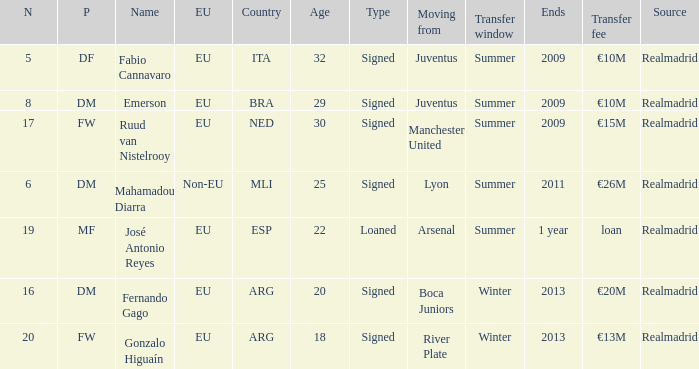How many numbers are ending in 1 year? 1.0. 